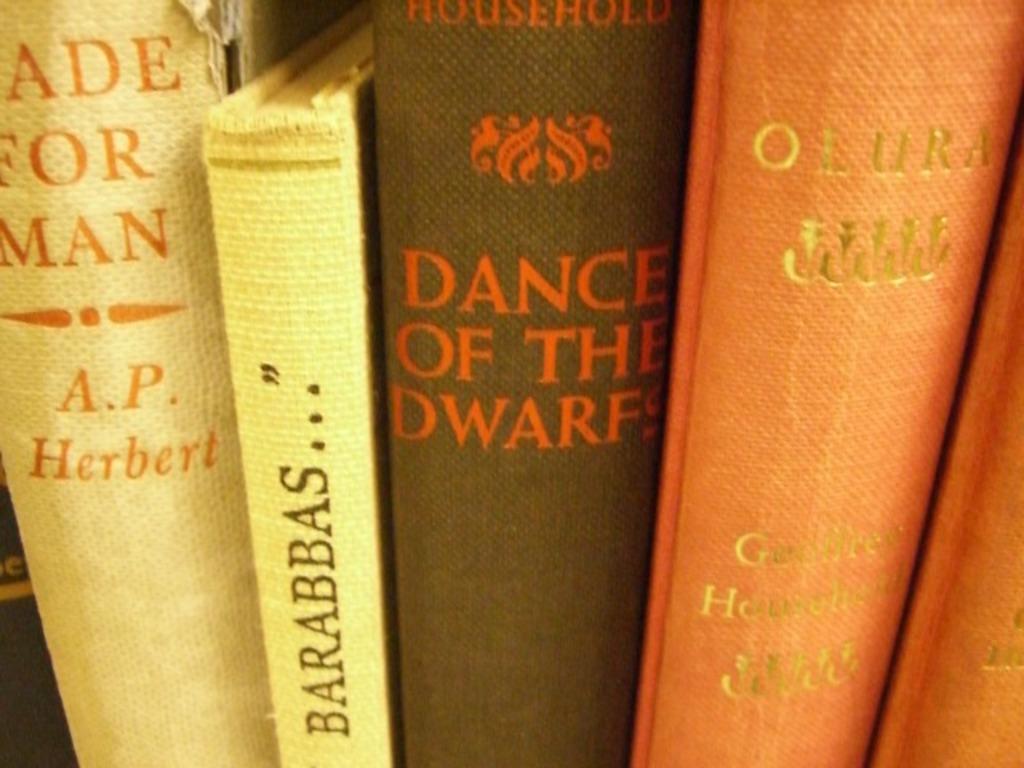Please provide a concise description of this image. In this image we can see some books with text, one book with text and image in the middle of the image. 